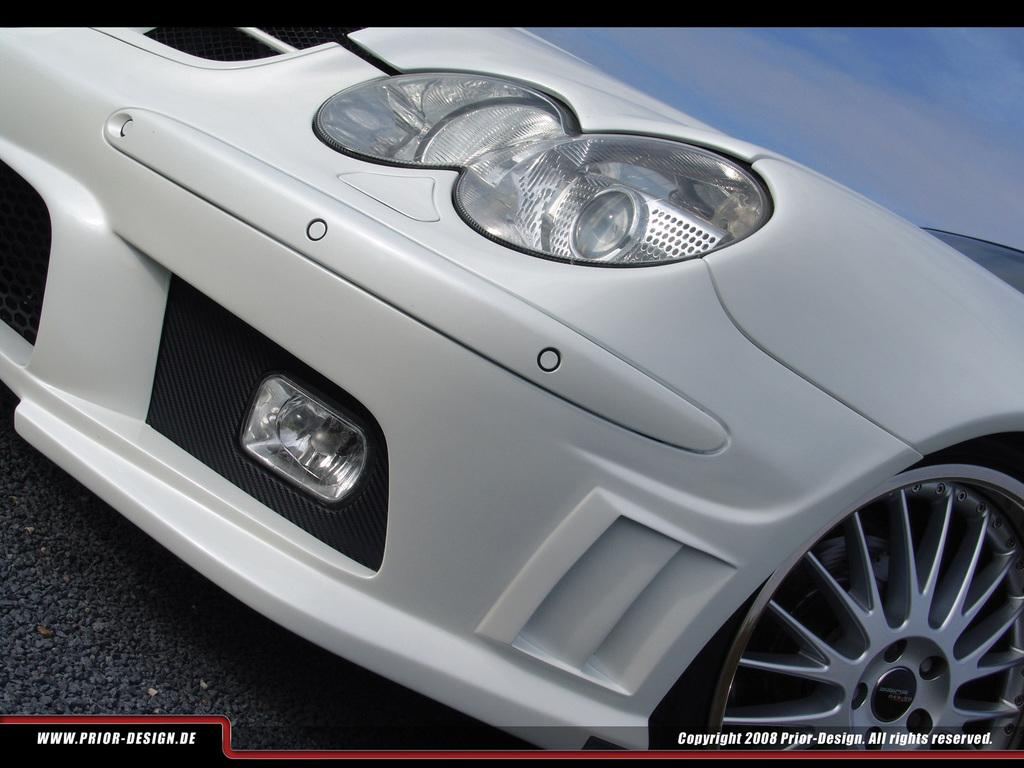What is the main subject in the front of the image? There is a car in the front of the image. Are there any visible marks or features on the image itself? Yes, there are watermarks on the bottom side of the image. What can be seen in the top right side of the image? Clouds and the sky are visible on the top right side of the image. What new discovery was made by the car in the image? There is no indication of a discovery being made by the car in the image. The car is simply parked or driving, and no new information is being uncovered. 